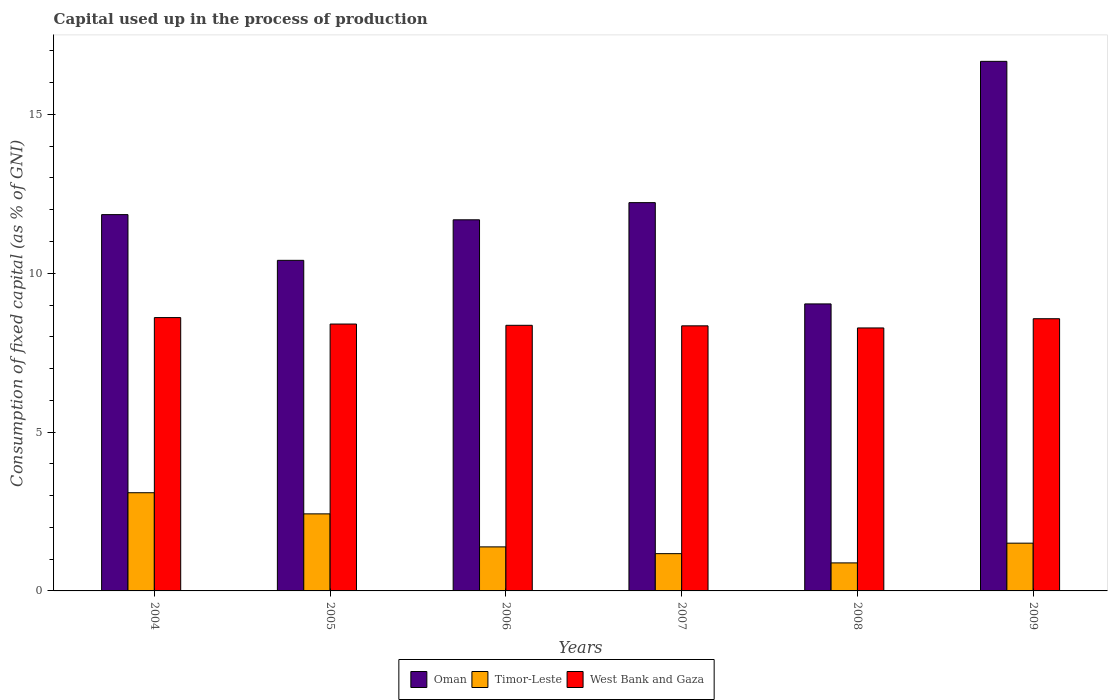How many groups of bars are there?
Offer a very short reply. 6. How many bars are there on the 2nd tick from the right?
Your answer should be very brief. 3. What is the capital used up in the process of production in Oman in 2005?
Offer a terse response. 10.41. Across all years, what is the maximum capital used up in the process of production in West Bank and Gaza?
Offer a very short reply. 8.61. Across all years, what is the minimum capital used up in the process of production in Oman?
Ensure brevity in your answer.  9.04. In which year was the capital used up in the process of production in Timor-Leste maximum?
Make the answer very short. 2004. What is the total capital used up in the process of production in Timor-Leste in the graph?
Make the answer very short. 10.46. What is the difference between the capital used up in the process of production in Oman in 2004 and that in 2009?
Keep it short and to the point. -4.83. What is the difference between the capital used up in the process of production in Oman in 2008 and the capital used up in the process of production in Timor-Leste in 2006?
Keep it short and to the point. 7.65. What is the average capital used up in the process of production in Oman per year?
Provide a succinct answer. 11.98. In the year 2006, what is the difference between the capital used up in the process of production in Oman and capital used up in the process of production in West Bank and Gaza?
Provide a succinct answer. 3.32. In how many years, is the capital used up in the process of production in Timor-Leste greater than 15 %?
Keep it short and to the point. 0. What is the ratio of the capital used up in the process of production in West Bank and Gaza in 2004 to that in 2009?
Provide a succinct answer. 1. Is the capital used up in the process of production in Oman in 2006 less than that in 2007?
Your response must be concise. Yes. Is the difference between the capital used up in the process of production in Oman in 2004 and 2009 greater than the difference between the capital used up in the process of production in West Bank and Gaza in 2004 and 2009?
Your answer should be very brief. No. What is the difference between the highest and the second highest capital used up in the process of production in Oman?
Provide a short and direct response. 4.45. What is the difference between the highest and the lowest capital used up in the process of production in Timor-Leste?
Your answer should be very brief. 2.21. In how many years, is the capital used up in the process of production in Timor-Leste greater than the average capital used up in the process of production in Timor-Leste taken over all years?
Provide a succinct answer. 2. Is the sum of the capital used up in the process of production in West Bank and Gaza in 2006 and 2009 greater than the maximum capital used up in the process of production in Oman across all years?
Your answer should be compact. Yes. What does the 1st bar from the left in 2008 represents?
Offer a very short reply. Oman. What does the 2nd bar from the right in 2006 represents?
Ensure brevity in your answer.  Timor-Leste. Are all the bars in the graph horizontal?
Your answer should be very brief. No. Are the values on the major ticks of Y-axis written in scientific E-notation?
Your response must be concise. No. Does the graph contain grids?
Offer a terse response. No. Where does the legend appear in the graph?
Provide a short and direct response. Bottom center. How many legend labels are there?
Make the answer very short. 3. What is the title of the graph?
Ensure brevity in your answer.  Capital used up in the process of production. Does "Equatorial Guinea" appear as one of the legend labels in the graph?
Your response must be concise. No. What is the label or title of the X-axis?
Your answer should be compact. Years. What is the label or title of the Y-axis?
Give a very brief answer. Consumption of fixed capital (as % of GNI). What is the Consumption of fixed capital (as % of GNI) of Oman in 2004?
Keep it short and to the point. 11.85. What is the Consumption of fixed capital (as % of GNI) in Timor-Leste in 2004?
Ensure brevity in your answer.  3.09. What is the Consumption of fixed capital (as % of GNI) of West Bank and Gaza in 2004?
Your answer should be compact. 8.61. What is the Consumption of fixed capital (as % of GNI) in Oman in 2005?
Keep it short and to the point. 10.41. What is the Consumption of fixed capital (as % of GNI) in Timor-Leste in 2005?
Make the answer very short. 2.43. What is the Consumption of fixed capital (as % of GNI) in West Bank and Gaza in 2005?
Your answer should be very brief. 8.4. What is the Consumption of fixed capital (as % of GNI) of Oman in 2006?
Your answer should be compact. 11.68. What is the Consumption of fixed capital (as % of GNI) in Timor-Leste in 2006?
Your answer should be compact. 1.39. What is the Consumption of fixed capital (as % of GNI) of West Bank and Gaza in 2006?
Your answer should be very brief. 8.36. What is the Consumption of fixed capital (as % of GNI) in Oman in 2007?
Provide a short and direct response. 12.22. What is the Consumption of fixed capital (as % of GNI) of Timor-Leste in 2007?
Provide a succinct answer. 1.17. What is the Consumption of fixed capital (as % of GNI) of West Bank and Gaza in 2007?
Give a very brief answer. 8.35. What is the Consumption of fixed capital (as % of GNI) of Oman in 2008?
Make the answer very short. 9.04. What is the Consumption of fixed capital (as % of GNI) in Timor-Leste in 2008?
Your answer should be compact. 0.88. What is the Consumption of fixed capital (as % of GNI) of West Bank and Gaza in 2008?
Your answer should be compact. 8.28. What is the Consumption of fixed capital (as % of GNI) of Oman in 2009?
Your response must be concise. 16.67. What is the Consumption of fixed capital (as % of GNI) of Timor-Leste in 2009?
Make the answer very short. 1.5. What is the Consumption of fixed capital (as % of GNI) in West Bank and Gaza in 2009?
Make the answer very short. 8.57. Across all years, what is the maximum Consumption of fixed capital (as % of GNI) in Oman?
Provide a short and direct response. 16.67. Across all years, what is the maximum Consumption of fixed capital (as % of GNI) in Timor-Leste?
Offer a very short reply. 3.09. Across all years, what is the maximum Consumption of fixed capital (as % of GNI) of West Bank and Gaza?
Provide a short and direct response. 8.61. Across all years, what is the minimum Consumption of fixed capital (as % of GNI) of Oman?
Your answer should be compact. 9.04. Across all years, what is the minimum Consumption of fixed capital (as % of GNI) of Timor-Leste?
Provide a succinct answer. 0.88. Across all years, what is the minimum Consumption of fixed capital (as % of GNI) of West Bank and Gaza?
Ensure brevity in your answer.  8.28. What is the total Consumption of fixed capital (as % of GNI) in Oman in the graph?
Ensure brevity in your answer.  71.87. What is the total Consumption of fixed capital (as % of GNI) in Timor-Leste in the graph?
Your response must be concise. 10.46. What is the total Consumption of fixed capital (as % of GNI) of West Bank and Gaza in the graph?
Provide a short and direct response. 50.56. What is the difference between the Consumption of fixed capital (as % of GNI) of Oman in 2004 and that in 2005?
Your response must be concise. 1.44. What is the difference between the Consumption of fixed capital (as % of GNI) in Timor-Leste in 2004 and that in 2005?
Offer a very short reply. 0.67. What is the difference between the Consumption of fixed capital (as % of GNI) of West Bank and Gaza in 2004 and that in 2005?
Ensure brevity in your answer.  0.2. What is the difference between the Consumption of fixed capital (as % of GNI) of Oman in 2004 and that in 2006?
Your answer should be very brief. 0.16. What is the difference between the Consumption of fixed capital (as % of GNI) of Timor-Leste in 2004 and that in 2006?
Provide a succinct answer. 1.71. What is the difference between the Consumption of fixed capital (as % of GNI) in West Bank and Gaza in 2004 and that in 2006?
Provide a succinct answer. 0.24. What is the difference between the Consumption of fixed capital (as % of GNI) of Oman in 2004 and that in 2007?
Offer a terse response. -0.38. What is the difference between the Consumption of fixed capital (as % of GNI) in Timor-Leste in 2004 and that in 2007?
Ensure brevity in your answer.  1.92. What is the difference between the Consumption of fixed capital (as % of GNI) of West Bank and Gaza in 2004 and that in 2007?
Offer a terse response. 0.26. What is the difference between the Consumption of fixed capital (as % of GNI) of Oman in 2004 and that in 2008?
Your response must be concise. 2.81. What is the difference between the Consumption of fixed capital (as % of GNI) of Timor-Leste in 2004 and that in 2008?
Provide a succinct answer. 2.21. What is the difference between the Consumption of fixed capital (as % of GNI) in West Bank and Gaza in 2004 and that in 2008?
Give a very brief answer. 0.33. What is the difference between the Consumption of fixed capital (as % of GNI) of Oman in 2004 and that in 2009?
Offer a very short reply. -4.83. What is the difference between the Consumption of fixed capital (as % of GNI) in Timor-Leste in 2004 and that in 2009?
Keep it short and to the point. 1.59. What is the difference between the Consumption of fixed capital (as % of GNI) in West Bank and Gaza in 2004 and that in 2009?
Ensure brevity in your answer.  0.04. What is the difference between the Consumption of fixed capital (as % of GNI) in Oman in 2005 and that in 2006?
Provide a succinct answer. -1.28. What is the difference between the Consumption of fixed capital (as % of GNI) of Timor-Leste in 2005 and that in 2006?
Your answer should be very brief. 1.04. What is the difference between the Consumption of fixed capital (as % of GNI) in West Bank and Gaza in 2005 and that in 2006?
Make the answer very short. 0.04. What is the difference between the Consumption of fixed capital (as % of GNI) of Oman in 2005 and that in 2007?
Provide a short and direct response. -1.82. What is the difference between the Consumption of fixed capital (as % of GNI) in Timor-Leste in 2005 and that in 2007?
Give a very brief answer. 1.25. What is the difference between the Consumption of fixed capital (as % of GNI) of West Bank and Gaza in 2005 and that in 2007?
Give a very brief answer. 0.06. What is the difference between the Consumption of fixed capital (as % of GNI) of Oman in 2005 and that in 2008?
Make the answer very short. 1.37. What is the difference between the Consumption of fixed capital (as % of GNI) in Timor-Leste in 2005 and that in 2008?
Your response must be concise. 1.54. What is the difference between the Consumption of fixed capital (as % of GNI) of West Bank and Gaza in 2005 and that in 2008?
Give a very brief answer. 0.12. What is the difference between the Consumption of fixed capital (as % of GNI) of Oman in 2005 and that in 2009?
Offer a very short reply. -6.26. What is the difference between the Consumption of fixed capital (as % of GNI) of Timor-Leste in 2005 and that in 2009?
Your answer should be very brief. 0.92. What is the difference between the Consumption of fixed capital (as % of GNI) in West Bank and Gaza in 2005 and that in 2009?
Your response must be concise. -0.17. What is the difference between the Consumption of fixed capital (as % of GNI) of Oman in 2006 and that in 2007?
Your response must be concise. -0.54. What is the difference between the Consumption of fixed capital (as % of GNI) of Timor-Leste in 2006 and that in 2007?
Give a very brief answer. 0.21. What is the difference between the Consumption of fixed capital (as % of GNI) in West Bank and Gaza in 2006 and that in 2007?
Your response must be concise. 0.02. What is the difference between the Consumption of fixed capital (as % of GNI) of Oman in 2006 and that in 2008?
Your answer should be very brief. 2.65. What is the difference between the Consumption of fixed capital (as % of GNI) of Timor-Leste in 2006 and that in 2008?
Offer a very short reply. 0.5. What is the difference between the Consumption of fixed capital (as % of GNI) of West Bank and Gaza in 2006 and that in 2008?
Offer a very short reply. 0.08. What is the difference between the Consumption of fixed capital (as % of GNI) in Oman in 2006 and that in 2009?
Keep it short and to the point. -4.99. What is the difference between the Consumption of fixed capital (as % of GNI) in Timor-Leste in 2006 and that in 2009?
Give a very brief answer. -0.12. What is the difference between the Consumption of fixed capital (as % of GNI) of West Bank and Gaza in 2006 and that in 2009?
Provide a short and direct response. -0.21. What is the difference between the Consumption of fixed capital (as % of GNI) in Oman in 2007 and that in 2008?
Your response must be concise. 3.19. What is the difference between the Consumption of fixed capital (as % of GNI) of Timor-Leste in 2007 and that in 2008?
Give a very brief answer. 0.29. What is the difference between the Consumption of fixed capital (as % of GNI) of West Bank and Gaza in 2007 and that in 2008?
Your answer should be compact. 0.07. What is the difference between the Consumption of fixed capital (as % of GNI) in Oman in 2007 and that in 2009?
Give a very brief answer. -4.45. What is the difference between the Consumption of fixed capital (as % of GNI) of Timor-Leste in 2007 and that in 2009?
Give a very brief answer. -0.33. What is the difference between the Consumption of fixed capital (as % of GNI) of West Bank and Gaza in 2007 and that in 2009?
Your answer should be very brief. -0.22. What is the difference between the Consumption of fixed capital (as % of GNI) in Oman in 2008 and that in 2009?
Your response must be concise. -7.64. What is the difference between the Consumption of fixed capital (as % of GNI) in Timor-Leste in 2008 and that in 2009?
Give a very brief answer. -0.62. What is the difference between the Consumption of fixed capital (as % of GNI) in West Bank and Gaza in 2008 and that in 2009?
Your answer should be compact. -0.29. What is the difference between the Consumption of fixed capital (as % of GNI) of Oman in 2004 and the Consumption of fixed capital (as % of GNI) of Timor-Leste in 2005?
Keep it short and to the point. 9.42. What is the difference between the Consumption of fixed capital (as % of GNI) of Oman in 2004 and the Consumption of fixed capital (as % of GNI) of West Bank and Gaza in 2005?
Your answer should be compact. 3.44. What is the difference between the Consumption of fixed capital (as % of GNI) of Timor-Leste in 2004 and the Consumption of fixed capital (as % of GNI) of West Bank and Gaza in 2005?
Your answer should be compact. -5.31. What is the difference between the Consumption of fixed capital (as % of GNI) in Oman in 2004 and the Consumption of fixed capital (as % of GNI) in Timor-Leste in 2006?
Offer a very short reply. 10.46. What is the difference between the Consumption of fixed capital (as % of GNI) in Oman in 2004 and the Consumption of fixed capital (as % of GNI) in West Bank and Gaza in 2006?
Offer a terse response. 3.48. What is the difference between the Consumption of fixed capital (as % of GNI) in Timor-Leste in 2004 and the Consumption of fixed capital (as % of GNI) in West Bank and Gaza in 2006?
Your answer should be compact. -5.27. What is the difference between the Consumption of fixed capital (as % of GNI) in Oman in 2004 and the Consumption of fixed capital (as % of GNI) in Timor-Leste in 2007?
Keep it short and to the point. 10.67. What is the difference between the Consumption of fixed capital (as % of GNI) in Oman in 2004 and the Consumption of fixed capital (as % of GNI) in West Bank and Gaza in 2007?
Your answer should be compact. 3.5. What is the difference between the Consumption of fixed capital (as % of GNI) in Timor-Leste in 2004 and the Consumption of fixed capital (as % of GNI) in West Bank and Gaza in 2007?
Provide a succinct answer. -5.25. What is the difference between the Consumption of fixed capital (as % of GNI) in Oman in 2004 and the Consumption of fixed capital (as % of GNI) in Timor-Leste in 2008?
Your answer should be compact. 10.96. What is the difference between the Consumption of fixed capital (as % of GNI) of Oman in 2004 and the Consumption of fixed capital (as % of GNI) of West Bank and Gaza in 2008?
Your answer should be very brief. 3.57. What is the difference between the Consumption of fixed capital (as % of GNI) of Timor-Leste in 2004 and the Consumption of fixed capital (as % of GNI) of West Bank and Gaza in 2008?
Keep it short and to the point. -5.19. What is the difference between the Consumption of fixed capital (as % of GNI) in Oman in 2004 and the Consumption of fixed capital (as % of GNI) in Timor-Leste in 2009?
Make the answer very short. 10.34. What is the difference between the Consumption of fixed capital (as % of GNI) of Oman in 2004 and the Consumption of fixed capital (as % of GNI) of West Bank and Gaza in 2009?
Make the answer very short. 3.28. What is the difference between the Consumption of fixed capital (as % of GNI) of Timor-Leste in 2004 and the Consumption of fixed capital (as % of GNI) of West Bank and Gaza in 2009?
Make the answer very short. -5.48. What is the difference between the Consumption of fixed capital (as % of GNI) of Oman in 2005 and the Consumption of fixed capital (as % of GNI) of Timor-Leste in 2006?
Offer a very short reply. 9.02. What is the difference between the Consumption of fixed capital (as % of GNI) of Oman in 2005 and the Consumption of fixed capital (as % of GNI) of West Bank and Gaza in 2006?
Your answer should be compact. 2.05. What is the difference between the Consumption of fixed capital (as % of GNI) in Timor-Leste in 2005 and the Consumption of fixed capital (as % of GNI) in West Bank and Gaza in 2006?
Keep it short and to the point. -5.94. What is the difference between the Consumption of fixed capital (as % of GNI) in Oman in 2005 and the Consumption of fixed capital (as % of GNI) in Timor-Leste in 2007?
Your response must be concise. 9.23. What is the difference between the Consumption of fixed capital (as % of GNI) in Oman in 2005 and the Consumption of fixed capital (as % of GNI) in West Bank and Gaza in 2007?
Provide a succinct answer. 2.06. What is the difference between the Consumption of fixed capital (as % of GNI) in Timor-Leste in 2005 and the Consumption of fixed capital (as % of GNI) in West Bank and Gaza in 2007?
Your answer should be compact. -5.92. What is the difference between the Consumption of fixed capital (as % of GNI) in Oman in 2005 and the Consumption of fixed capital (as % of GNI) in Timor-Leste in 2008?
Your response must be concise. 9.53. What is the difference between the Consumption of fixed capital (as % of GNI) of Oman in 2005 and the Consumption of fixed capital (as % of GNI) of West Bank and Gaza in 2008?
Offer a terse response. 2.13. What is the difference between the Consumption of fixed capital (as % of GNI) of Timor-Leste in 2005 and the Consumption of fixed capital (as % of GNI) of West Bank and Gaza in 2008?
Your answer should be compact. -5.85. What is the difference between the Consumption of fixed capital (as % of GNI) in Oman in 2005 and the Consumption of fixed capital (as % of GNI) in Timor-Leste in 2009?
Offer a terse response. 8.9. What is the difference between the Consumption of fixed capital (as % of GNI) of Oman in 2005 and the Consumption of fixed capital (as % of GNI) of West Bank and Gaza in 2009?
Keep it short and to the point. 1.84. What is the difference between the Consumption of fixed capital (as % of GNI) in Timor-Leste in 2005 and the Consumption of fixed capital (as % of GNI) in West Bank and Gaza in 2009?
Give a very brief answer. -6.14. What is the difference between the Consumption of fixed capital (as % of GNI) in Oman in 2006 and the Consumption of fixed capital (as % of GNI) in Timor-Leste in 2007?
Keep it short and to the point. 10.51. What is the difference between the Consumption of fixed capital (as % of GNI) of Oman in 2006 and the Consumption of fixed capital (as % of GNI) of West Bank and Gaza in 2007?
Provide a succinct answer. 3.34. What is the difference between the Consumption of fixed capital (as % of GNI) of Timor-Leste in 2006 and the Consumption of fixed capital (as % of GNI) of West Bank and Gaza in 2007?
Make the answer very short. -6.96. What is the difference between the Consumption of fixed capital (as % of GNI) of Oman in 2006 and the Consumption of fixed capital (as % of GNI) of Timor-Leste in 2008?
Offer a very short reply. 10.8. What is the difference between the Consumption of fixed capital (as % of GNI) of Oman in 2006 and the Consumption of fixed capital (as % of GNI) of West Bank and Gaza in 2008?
Give a very brief answer. 3.4. What is the difference between the Consumption of fixed capital (as % of GNI) in Timor-Leste in 2006 and the Consumption of fixed capital (as % of GNI) in West Bank and Gaza in 2008?
Your answer should be compact. -6.89. What is the difference between the Consumption of fixed capital (as % of GNI) in Oman in 2006 and the Consumption of fixed capital (as % of GNI) in Timor-Leste in 2009?
Keep it short and to the point. 10.18. What is the difference between the Consumption of fixed capital (as % of GNI) of Oman in 2006 and the Consumption of fixed capital (as % of GNI) of West Bank and Gaza in 2009?
Give a very brief answer. 3.11. What is the difference between the Consumption of fixed capital (as % of GNI) of Timor-Leste in 2006 and the Consumption of fixed capital (as % of GNI) of West Bank and Gaza in 2009?
Give a very brief answer. -7.18. What is the difference between the Consumption of fixed capital (as % of GNI) in Oman in 2007 and the Consumption of fixed capital (as % of GNI) in Timor-Leste in 2008?
Provide a succinct answer. 11.34. What is the difference between the Consumption of fixed capital (as % of GNI) of Oman in 2007 and the Consumption of fixed capital (as % of GNI) of West Bank and Gaza in 2008?
Provide a short and direct response. 3.95. What is the difference between the Consumption of fixed capital (as % of GNI) in Timor-Leste in 2007 and the Consumption of fixed capital (as % of GNI) in West Bank and Gaza in 2008?
Make the answer very short. -7.11. What is the difference between the Consumption of fixed capital (as % of GNI) in Oman in 2007 and the Consumption of fixed capital (as % of GNI) in Timor-Leste in 2009?
Keep it short and to the point. 10.72. What is the difference between the Consumption of fixed capital (as % of GNI) in Oman in 2007 and the Consumption of fixed capital (as % of GNI) in West Bank and Gaza in 2009?
Offer a terse response. 3.65. What is the difference between the Consumption of fixed capital (as % of GNI) of Timor-Leste in 2007 and the Consumption of fixed capital (as % of GNI) of West Bank and Gaza in 2009?
Offer a terse response. -7.4. What is the difference between the Consumption of fixed capital (as % of GNI) in Oman in 2008 and the Consumption of fixed capital (as % of GNI) in Timor-Leste in 2009?
Make the answer very short. 7.53. What is the difference between the Consumption of fixed capital (as % of GNI) in Oman in 2008 and the Consumption of fixed capital (as % of GNI) in West Bank and Gaza in 2009?
Offer a very short reply. 0.47. What is the difference between the Consumption of fixed capital (as % of GNI) in Timor-Leste in 2008 and the Consumption of fixed capital (as % of GNI) in West Bank and Gaza in 2009?
Provide a succinct answer. -7.69. What is the average Consumption of fixed capital (as % of GNI) of Oman per year?
Offer a very short reply. 11.98. What is the average Consumption of fixed capital (as % of GNI) of Timor-Leste per year?
Your answer should be very brief. 1.74. What is the average Consumption of fixed capital (as % of GNI) in West Bank and Gaza per year?
Your answer should be compact. 8.43. In the year 2004, what is the difference between the Consumption of fixed capital (as % of GNI) of Oman and Consumption of fixed capital (as % of GNI) of Timor-Leste?
Offer a very short reply. 8.76. In the year 2004, what is the difference between the Consumption of fixed capital (as % of GNI) in Oman and Consumption of fixed capital (as % of GNI) in West Bank and Gaza?
Ensure brevity in your answer.  3.24. In the year 2004, what is the difference between the Consumption of fixed capital (as % of GNI) in Timor-Leste and Consumption of fixed capital (as % of GNI) in West Bank and Gaza?
Give a very brief answer. -5.51. In the year 2005, what is the difference between the Consumption of fixed capital (as % of GNI) of Oman and Consumption of fixed capital (as % of GNI) of Timor-Leste?
Give a very brief answer. 7.98. In the year 2005, what is the difference between the Consumption of fixed capital (as % of GNI) in Oman and Consumption of fixed capital (as % of GNI) in West Bank and Gaza?
Provide a short and direct response. 2.01. In the year 2005, what is the difference between the Consumption of fixed capital (as % of GNI) in Timor-Leste and Consumption of fixed capital (as % of GNI) in West Bank and Gaza?
Make the answer very short. -5.98. In the year 2006, what is the difference between the Consumption of fixed capital (as % of GNI) of Oman and Consumption of fixed capital (as % of GNI) of Timor-Leste?
Your response must be concise. 10.3. In the year 2006, what is the difference between the Consumption of fixed capital (as % of GNI) in Oman and Consumption of fixed capital (as % of GNI) in West Bank and Gaza?
Make the answer very short. 3.32. In the year 2006, what is the difference between the Consumption of fixed capital (as % of GNI) in Timor-Leste and Consumption of fixed capital (as % of GNI) in West Bank and Gaza?
Keep it short and to the point. -6.98. In the year 2007, what is the difference between the Consumption of fixed capital (as % of GNI) in Oman and Consumption of fixed capital (as % of GNI) in Timor-Leste?
Make the answer very short. 11.05. In the year 2007, what is the difference between the Consumption of fixed capital (as % of GNI) of Oman and Consumption of fixed capital (as % of GNI) of West Bank and Gaza?
Provide a short and direct response. 3.88. In the year 2007, what is the difference between the Consumption of fixed capital (as % of GNI) of Timor-Leste and Consumption of fixed capital (as % of GNI) of West Bank and Gaza?
Your response must be concise. -7.17. In the year 2008, what is the difference between the Consumption of fixed capital (as % of GNI) in Oman and Consumption of fixed capital (as % of GNI) in Timor-Leste?
Provide a succinct answer. 8.15. In the year 2008, what is the difference between the Consumption of fixed capital (as % of GNI) in Oman and Consumption of fixed capital (as % of GNI) in West Bank and Gaza?
Give a very brief answer. 0.76. In the year 2008, what is the difference between the Consumption of fixed capital (as % of GNI) of Timor-Leste and Consumption of fixed capital (as % of GNI) of West Bank and Gaza?
Your answer should be very brief. -7.4. In the year 2009, what is the difference between the Consumption of fixed capital (as % of GNI) in Oman and Consumption of fixed capital (as % of GNI) in Timor-Leste?
Make the answer very short. 15.17. In the year 2009, what is the difference between the Consumption of fixed capital (as % of GNI) of Oman and Consumption of fixed capital (as % of GNI) of West Bank and Gaza?
Make the answer very short. 8.1. In the year 2009, what is the difference between the Consumption of fixed capital (as % of GNI) in Timor-Leste and Consumption of fixed capital (as % of GNI) in West Bank and Gaza?
Keep it short and to the point. -7.07. What is the ratio of the Consumption of fixed capital (as % of GNI) of Oman in 2004 to that in 2005?
Offer a terse response. 1.14. What is the ratio of the Consumption of fixed capital (as % of GNI) of Timor-Leste in 2004 to that in 2005?
Provide a short and direct response. 1.27. What is the ratio of the Consumption of fixed capital (as % of GNI) of West Bank and Gaza in 2004 to that in 2005?
Your response must be concise. 1.02. What is the ratio of the Consumption of fixed capital (as % of GNI) in Oman in 2004 to that in 2006?
Your answer should be compact. 1.01. What is the ratio of the Consumption of fixed capital (as % of GNI) in Timor-Leste in 2004 to that in 2006?
Keep it short and to the point. 2.23. What is the ratio of the Consumption of fixed capital (as % of GNI) in West Bank and Gaza in 2004 to that in 2006?
Make the answer very short. 1.03. What is the ratio of the Consumption of fixed capital (as % of GNI) in Oman in 2004 to that in 2007?
Offer a terse response. 0.97. What is the ratio of the Consumption of fixed capital (as % of GNI) in Timor-Leste in 2004 to that in 2007?
Offer a very short reply. 2.63. What is the ratio of the Consumption of fixed capital (as % of GNI) in West Bank and Gaza in 2004 to that in 2007?
Give a very brief answer. 1.03. What is the ratio of the Consumption of fixed capital (as % of GNI) in Oman in 2004 to that in 2008?
Ensure brevity in your answer.  1.31. What is the ratio of the Consumption of fixed capital (as % of GNI) of Timor-Leste in 2004 to that in 2008?
Offer a very short reply. 3.5. What is the ratio of the Consumption of fixed capital (as % of GNI) of West Bank and Gaza in 2004 to that in 2008?
Give a very brief answer. 1.04. What is the ratio of the Consumption of fixed capital (as % of GNI) in Oman in 2004 to that in 2009?
Keep it short and to the point. 0.71. What is the ratio of the Consumption of fixed capital (as % of GNI) in Timor-Leste in 2004 to that in 2009?
Offer a terse response. 2.06. What is the ratio of the Consumption of fixed capital (as % of GNI) in Oman in 2005 to that in 2006?
Make the answer very short. 0.89. What is the ratio of the Consumption of fixed capital (as % of GNI) of Timor-Leste in 2005 to that in 2006?
Offer a very short reply. 1.75. What is the ratio of the Consumption of fixed capital (as % of GNI) of West Bank and Gaza in 2005 to that in 2006?
Offer a terse response. 1. What is the ratio of the Consumption of fixed capital (as % of GNI) of Oman in 2005 to that in 2007?
Your response must be concise. 0.85. What is the ratio of the Consumption of fixed capital (as % of GNI) of Timor-Leste in 2005 to that in 2007?
Offer a very short reply. 2.07. What is the ratio of the Consumption of fixed capital (as % of GNI) of West Bank and Gaza in 2005 to that in 2007?
Give a very brief answer. 1.01. What is the ratio of the Consumption of fixed capital (as % of GNI) of Oman in 2005 to that in 2008?
Your answer should be very brief. 1.15. What is the ratio of the Consumption of fixed capital (as % of GNI) in Timor-Leste in 2005 to that in 2008?
Provide a succinct answer. 2.75. What is the ratio of the Consumption of fixed capital (as % of GNI) of West Bank and Gaza in 2005 to that in 2008?
Your response must be concise. 1.01. What is the ratio of the Consumption of fixed capital (as % of GNI) in Oman in 2005 to that in 2009?
Ensure brevity in your answer.  0.62. What is the ratio of the Consumption of fixed capital (as % of GNI) of Timor-Leste in 2005 to that in 2009?
Your answer should be compact. 1.61. What is the ratio of the Consumption of fixed capital (as % of GNI) in West Bank and Gaza in 2005 to that in 2009?
Make the answer very short. 0.98. What is the ratio of the Consumption of fixed capital (as % of GNI) in Oman in 2006 to that in 2007?
Provide a short and direct response. 0.96. What is the ratio of the Consumption of fixed capital (as % of GNI) of Timor-Leste in 2006 to that in 2007?
Provide a short and direct response. 1.18. What is the ratio of the Consumption of fixed capital (as % of GNI) in Oman in 2006 to that in 2008?
Provide a succinct answer. 1.29. What is the ratio of the Consumption of fixed capital (as % of GNI) in Timor-Leste in 2006 to that in 2008?
Give a very brief answer. 1.57. What is the ratio of the Consumption of fixed capital (as % of GNI) in West Bank and Gaza in 2006 to that in 2008?
Provide a succinct answer. 1.01. What is the ratio of the Consumption of fixed capital (as % of GNI) in Oman in 2006 to that in 2009?
Make the answer very short. 0.7. What is the ratio of the Consumption of fixed capital (as % of GNI) in Timor-Leste in 2006 to that in 2009?
Your answer should be very brief. 0.92. What is the ratio of the Consumption of fixed capital (as % of GNI) in West Bank and Gaza in 2006 to that in 2009?
Provide a succinct answer. 0.98. What is the ratio of the Consumption of fixed capital (as % of GNI) in Oman in 2007 to that in 2008?
Ensure brevity in your answer.  1.35. What is the ratio of the Consumption of fixed capital (as % of GNI) in Timor-Leste in 2007 to that in 2008?
Ensure brevity in your answer.  1.33. What is the ratio of the Consumption of fixed capital (as % of GNI) in West Bank and Gaza in 2007 to that in 2008?
Your answer should be very brief. 1.01. What is the ratio of the Consumption of fixed capital (as % of GNI) in Oman in 2007 to that in 2009?
Provide a succinct answer. 0.73. What is the ratio of the Consumption of fixed capital (as % of GNI) of Timor-Leste in 2007 to that in 2009?
Make the answer very short. 0.78. What is the ratio of the Consumption of fixed capital (as % of GNI) in West Bank and Gaza in 2007 to that in 2009?
Your answer should be compact. 0.97. What is the ratio of the Consumption of fixed capital (as % of GNI) of Oman in 2008 to that in 2009?
Ensure brevity in your answer.  0.54. What is the ratio of the Consumption of fixed capital (as % of GNI) of Timor-Leste in 2008 to that in 2009?
Offer a terse response. 0.59. What is the ratio of the Consumption of fixed capital (as % of GNI) in West Bank and Gaza in 2008 to that in 2009?
Ensure brevity in your answer.  0.97. What is the difference between the highest and the second highest Consumption of fixed capital (as % of GNI) of Oman?
Your answer should be very brief. 4.45. What is the difference between the highest and the second highest Consumption of fixed capital (as % of GNI) of Timor-Leste?
Ensure brevity in your answer.  0.67. What is the difference between the highest and the second highest Consumption of fixed capital (as % of GNI) in West Bank and Gaza?
Make the answer very short. 0.04. What is the difference between the highest and the lowest Consumption of fixed capital (as % of GNI) of Oman?
Provide a short and direct response. 7.64. What is the difference between the highest and the lowest Consumption of fixed capital (as % of GNI) of Timor-Leste?
Ensure brevity in your answer.  2.21. What is the difference between the highest and the lowest Consumption of fixed capital (as % of GNI) in West Bank and Gaza?
Keep it short and to the point. 0.33. 